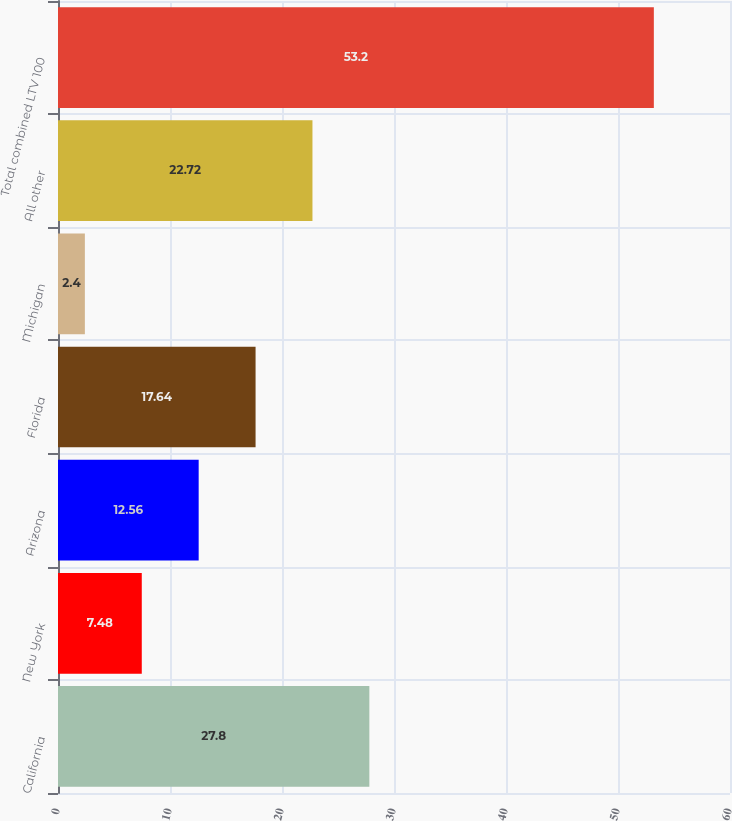Convert chart. <chart><loc_0><loc_0><loc_500><loc_500><bar_chart><fcel>California<fcel>New York<fcel>Arizona<fcel>Florida<fcel>Michigan<fcel>All other<fcel>Total combined LTV 100<nl><fcel>27.8<fcel>7.48<fcel>12.56<fcel>17.64<fcel>2.4<fcel>22.72<fcel>53.2<nl></chart> 